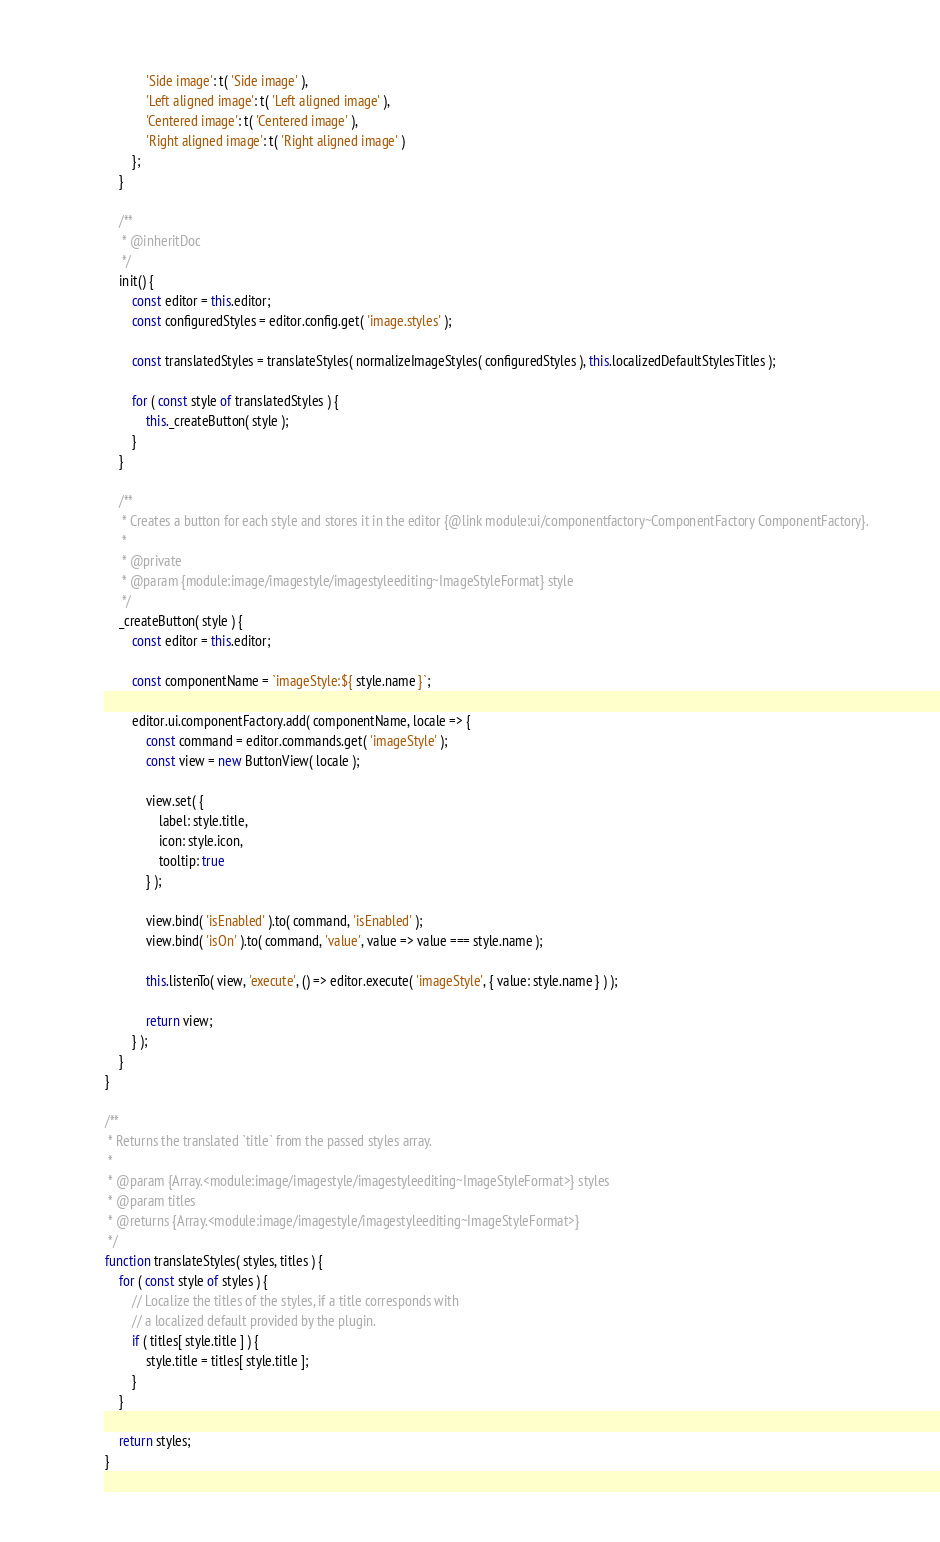Convert code to text. <code><loc_0><loc_0><loc_500><loc_500><_JavaScript_>			'Side image': t( 'Side image' ),
			'Left aligned image': t( 'Left aligned image' ),
			'Centered image': t( 'Centered image' ),
			'Right aligned image': t( 'Right aligned image' )
		};
	}

	/**
	 * @inheritDoc
	 */
	init() {
		const editor = this.editor;
		const configuredStyles = editor.config.get( 'image.styles' );

		const translatedStyles = translateStyles( normalizeImageStyles( configuredStyles ), this.localizedDefaultStylesTitles );

		for ( const style of translatedStyles ) {
			this._createButton( style );
		}
	}

	/**
	 * Creates a button for each style and stores it in the editor {@link module:ui/componentfactory~ComponentFactory ComponentFactory}.
	 *
	 * @private
	 * @param {module:image/imagestyle/imagestyleediting~ImageStyleFormat} style
	 */
	_createButton( style ) {
		const editor = this.editor;

		const componentName = `imageStyle:${ style.name }`;

		editor.ui.componentFactory.add( componentName, locale => {
			const command = editor.commands.get( 'imageStyle' );
			const view = new ButtonView( locale );

			view.set( {
				label: style.title,
				icon: style.icon,
				tooltip: true
			} );

			view.bind( 'isEnabled' ).to( command, 'isEnabled' );
			view.bind( 'isOn' ).to( command, 'value', value => value === style.name );

			this.listenTo( view, 'execute', () => editor.execute( 'imageStyle', { value: style.name } ) );

			return view;
		} );
	}
}

/**
 * Returns the translated `title` from the passed styles array.
 *
 * @param {Array.<module:image/imagestyle/imagestyleediting~ImageStyleFormat>} styles
 * @param titles
 * @returns {Array.<module:image/imagestyle/imagestyleediting~ImageStyleFormat>}
 */
function translateStyles( styles, titles ) {
	for ( const style of styles ) {
		// Localize the titles of the styles, if a title corresponds with
		// a localized default provided by the plugin.
		if ( titles[ style.title ] ) {
			style.title = titles[ style.title ];
		}
	}

	return styles;
}
</code> 